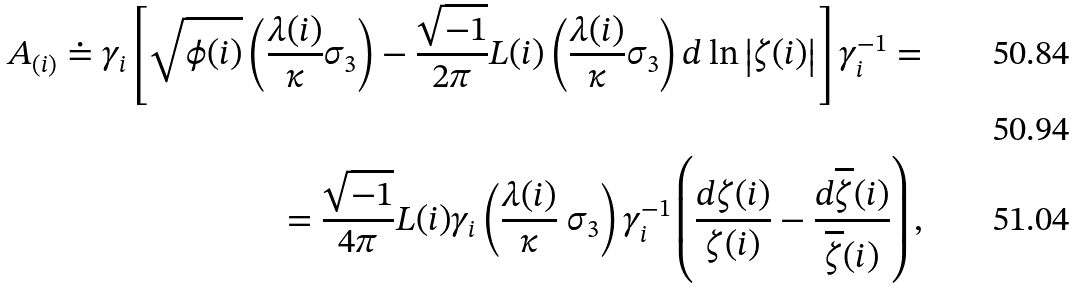<formula> <loc_0><loc_0><loc_500><loc_500>A _ { ( i ) } \doteq \gamma _ { i } \left [ \sqrt { \phi ( i ) } \left ( \frac { \lambda ( i ) } { \kappa } \sigma _ { 3 } \right ) - \frac { \sqrt { - 1 } } { 2 \pi } L ( i ) \left ( \frac { \lambda ( i ) } { \kappa } \sigma _ { 3 } \right ) d \ln \left | \zeta ( i ) \right | \right ] \gamma _ { i } ^ { - 1 } = \\ \\ = \frac { \sqrt { - 1 } } { 4 \pi } L ( i ) \gamma _ { i } \left ( \frac { \lambda ( i ) } { \kappa } \ \sigma _ { 3 } \right ) \gamma _ { i } ^ { - 1 } \left ( \frac { d \zeta ( i ) } { \zeta ( i ) } - \frac { d \overline { \zeta } ( i ) } { \overline { \zeta } ( i ) } \right ) ,</formula> 